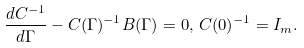<formula> <loc_0><loc_0><loc_500><loc_500>\frac { d C ^ { - 1 } } { d \Gamma } - C ( \Gamma ) ^ { - 1 } B ( \Gamma ) = 0 , \, C ( 0 ) ^ { - 1 } = I _ { m } .</formula> 